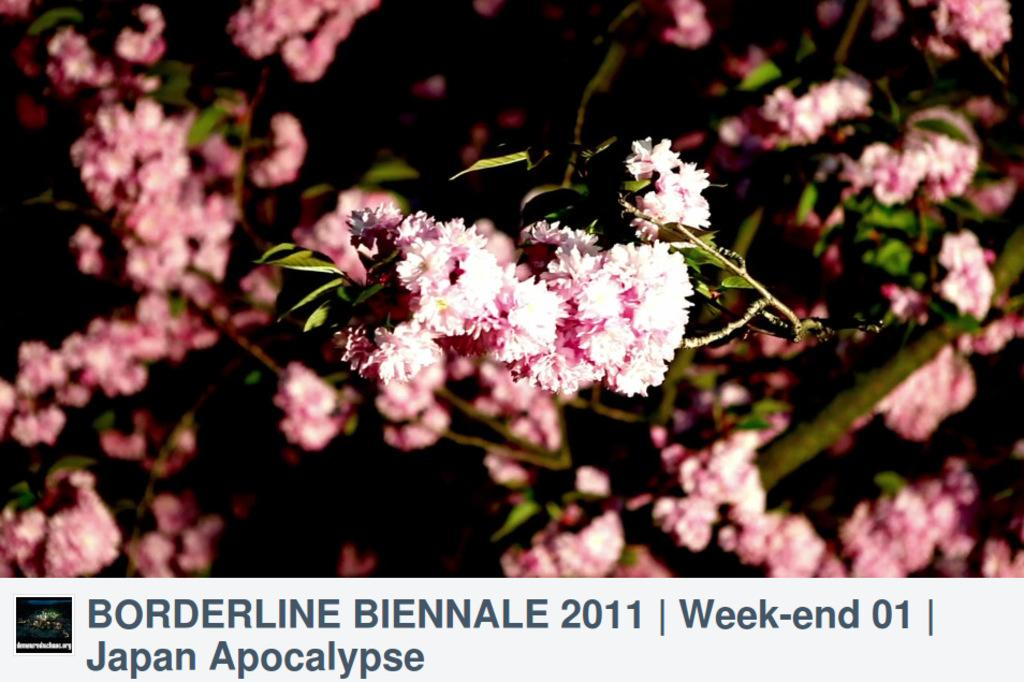What type of flower is in the image? There is a pink flower in the image. What other parts of the flower can be seen? The flower has leaves. What supports the flower in the image? There is a stem in the background of the flower. What is written or displayed at the bottom of the image? Some text is written at the bottom of the image. What type of alarm can be heard going off in the image? There is no alarm present in the image, as it is a still image of a flower. 